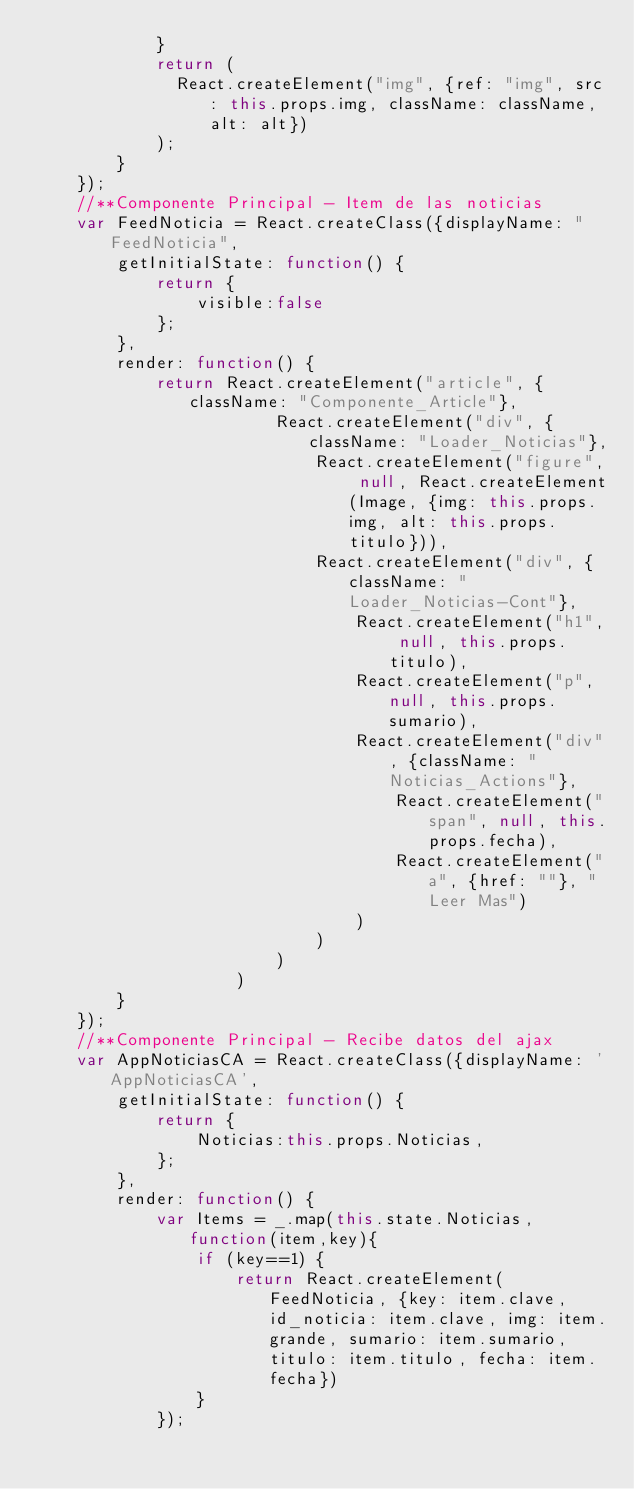<code> <loc_0><loc_0><loc_500><loc_500><_JavaScript_>			}
			return (
			  React.createElement("img", {ref: "img", src: this.props.img, className: className, alt: alt})
			);
		}
	});
	//**Componente Principal - Item de las noticias
	var FeedNoticia = React.createClass({displayName: "FeedNoticia",
		getInitialState: function() {
			return {
				visible:false 
			};
		},
		render: function() {
			return React.createElement("article", {className: "Componente_Article"}, 
						React.createElement("div", {className: "Loader_Noticias"}, 
		                    React.createElement("figure", null, React.createElement(Image, {img: this.props.img, alt: this.props.titulo})), 
		                    React.createElement("div", {className: "Loader_Noticias-Cont"}, 
		                        React.createElement("h1", null, this.props.titulo), 
		                        React.createElement("p", null, this.props.sumario), 
		                        React.createElement("div", {className: "Noticias_Actions"}, 
		                        	React.createElement("span", null, this.props.fecha), 
		                        	React.createElement("a", {href: ""}, "Leer Mas")
		                        )
		                    )
		                )
	            	)		
		}
	});
	//**Componente Principal - Recibe datos del ajax
	var AppNoticiasCA = React.createClass({displayName: 'AppNoticiasCA',
		getInitialState: function() {
			return {
				Noticias:this.props.Noticias, 
			};
		},
		render: function() {
			var Items = _.map(this.state.Noticias, function(item,key){ 
				if (key==1) {
					return React.createElement(FeedNoticia, {key: item.clave, id_noticia: item.clave, img: item.grande, sumario: item.sumario, titulo: item.titulo, fecha: item.fecha})
				}
			});	</code> 